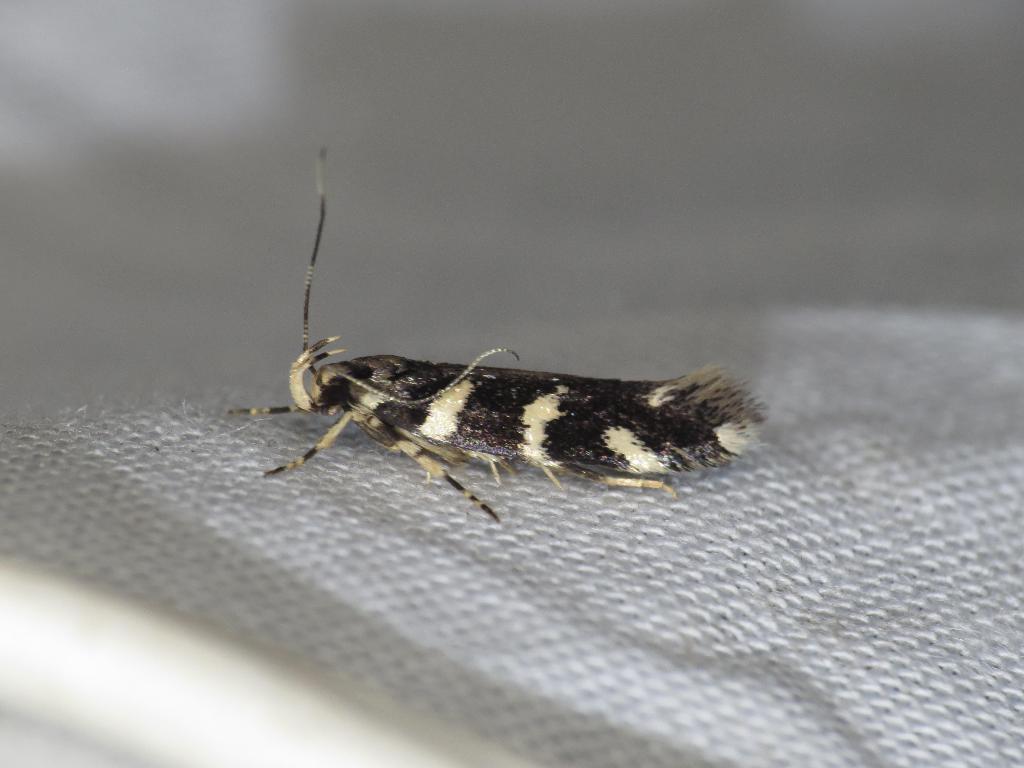Can you describe this image briefly? As we can see in the image, there is black and white color insect on white color cloth. 